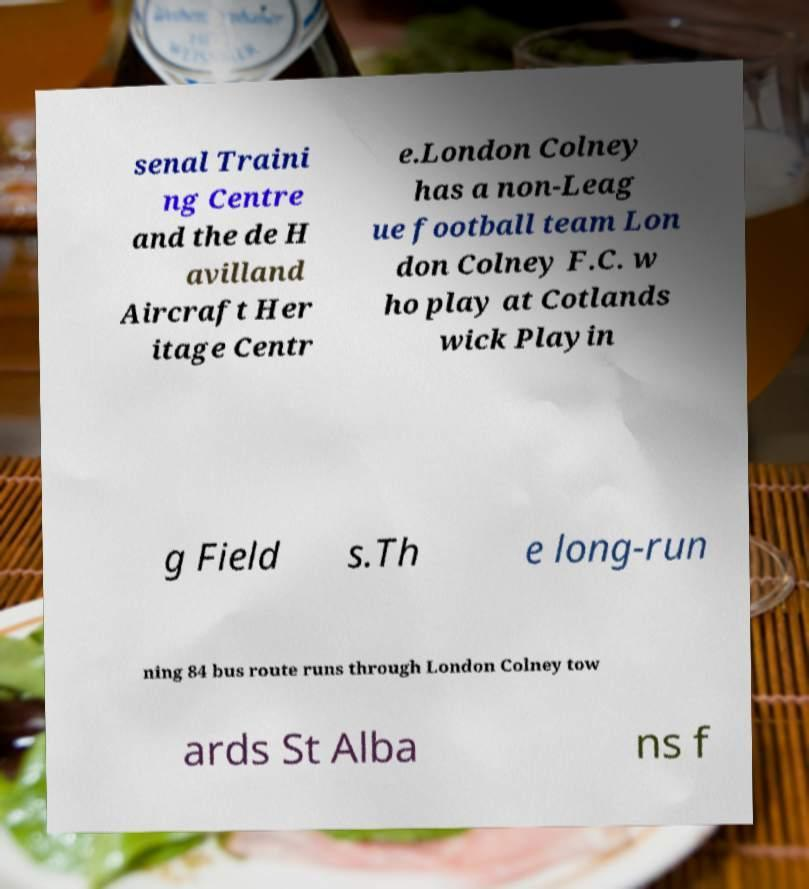Can you accurately transcribe the text from the provided image for me? senal Traini ng Centre and the de H avilland Aircraft Her itage Centr e.London Colney has a non-Leag ue football team Lon don Colney F.C. w ho play at Cotlands wick Playin g Field s.Th e long-run ning 84 bus route runs through London Colney tow ards St Alba ns f 